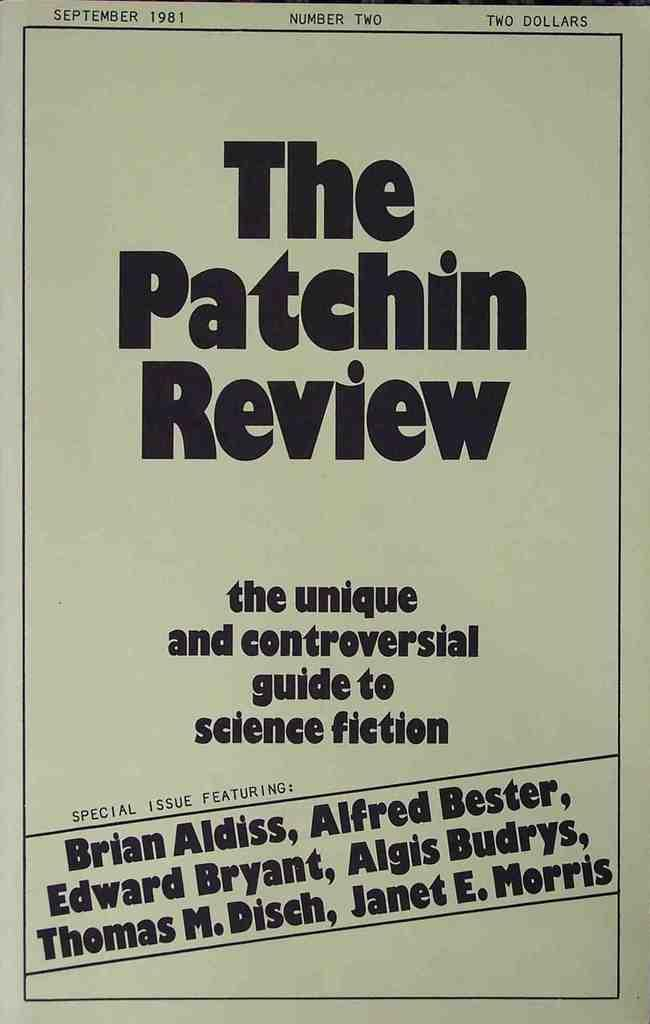<image>
Write a terse but informative summary of the picture. An issue of the Patchin Review dated September 1981. 